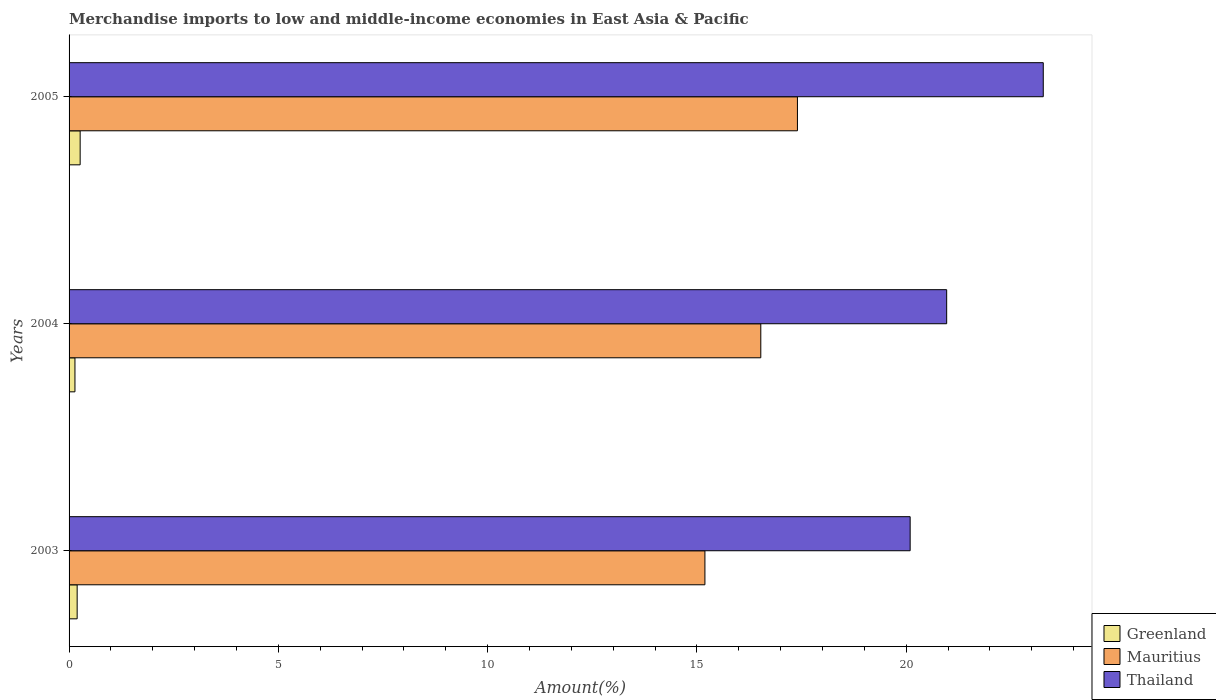How many groups of bars are there?
Offer a terse response. 3. How many bars are there on the 3rd tick from the top?
Your response must be concise. 3. How many bars are there on the 1st tick from the bottom?
Your answer should be compact. 3. What is the percentage of amount earned from merchandise imports in Mauritius in 2003?
Offer a terse response. 15.19. Across all years, what is the maximum percentage of amount earned from merchandise imports in Greenland?
Your answer should be compact. 0.26. Across all years, what is the minimum percentage of amount earned from merchandise imports in Greenland?
Your response must be concise. 0.14. In which year was the percentage of amount earned from merchandise imports in Thailand maximum?
Keep it short and to the point. 2005. What is the total percentage of amount earned from merchandise imports in Greenland in the graph?
Make the answer very short. 0.6. What is the difference between the percentage of amount earned from merchandise imports in Mauritius in 2003 and that in 2004?
Offer a very short reply. -1.33. What is the difference between the percentage of amount earned from merchandise imports in Greenland in 2004 and the percentage of amount earned from merchandise imports in Thailand in 2003?
Provide a short and direct response. -19.95. What is the average percentage of amount earned from merchandise imports in Thailand per year?
Make the answer very short. 21.44. In the year 2003, what is the difference between the percentage of amount earned from merchandise imports in Greenland and percentage of amount earned from merchandise imports in Thailand?
Offer a very short reply. -19.9. What is the ratio of the percentage of amount earned from merchandise imports in Greenland in 2003 to that in 2005?
Your answer should be compact. 0.73. What is the difference between the highest and the second highest percentage of amount earned from merchandise imports in Mauritius?
Keep it short and to the point. 0.88. What is the difference between the highest and the lowest percentage of amount earned from merchandise imports in Mauritius?
Keep it short and to the point. 2.21. Is the sum of the percentage of amount earned from merchandise imports in Mauritius in 2004 and 2005 greater than the maximum percentage of amount earned from merchandise imports in Thailand across all years?
Your answer should be very brief. Yes. What does the 2nd bar from the top in 2004 represents?
Provide a short and direct response. Mauritius. What does the 3rd bar from the bottom in 2005 represents?
Provide a succinct answer. Thailand. Is it the case that in every year, the sum of the percentage of amount earned from merchandise imports in Thailand and percentage of amount earned from merchandise imports in Greenland is greater than the percentage of amount earned from merchandise imports in Mauritius?
Your answer should be very brief. Yes. Are all the bars in the graph horizontal?
Your answer should be compact. Yes. What is the difference between two consecutive major ticks on the X-axis?
Offer a terse response. 5. Does the graph contain any zero values?
Your answer should be very brief. No. How many legend labels are there?
Your answer should be compact. 3. What is the title of the graph?
Offer a very short reply. Merchandise imports to low and middle-income economies in East Asia & Pacific. Does "Belize" appear as one of the legend labels in the graph?
Keep it short and to the point. No. What is the label or title of the X-axis?
Keep it short and to the point. Amount(%). What is the Amount(%) in Greenland in 2003?
Offer a terse response. 0.19. What is the Amount(%) of Mauritius in 2003?
Provide a succinct answer. 15.19. What is the Amount(%) in Thailand in 2003?
Keep it short and to the point. 20.09. What is the Amount(%) of Greenland in 2004?
Ensure brevity in your answer.  0.14. What is the Amount(%) of Mauritius in 2004?
Provide a succinct answer. 16.53. What is the Amount(%) of Thailand in 2004?
Your answer should be very brief. 20.97. What is the Amount(%) in Greenland in 2005?
Keep it short and to the point. 0.26. What is the Amount(%) of Mauritius in 2005?
Provide a succinct answer. 17.4. What is the Amount(%) of Thailand in 2005?
Your response must be concise. 23.27. Across all years, what is the maximum Amount(%) of Greenland?
Keep it short and to the point. 0.26. Across all years, what is the maximum Amount(%) in Mauritius?
Keep it short and to the point. 17.4. Across all years, what is the maximum Amount(%) of Thailand?
Offer a very short reply. 23.27. Across all years, what is the minimum Amount(%) of Greenland?
Make the answer very short. 0.14. Across all years, what is the minimum Amount(%) of Mauritius?
Your response must be concise. 15.19. Across all years, what is the minimum Amount(%) in Thailand?
Keep it short and to the point. 20.09. What is the total Amount(%) in Greenland in the graph?
Provide a short and direct response. 0.6. What is the total Amount(%) in Mauritius in the graph?
Your response must be concise. 49.12. What is the total Amount(%) of Thailand in the graph?
Your response must be concise. 64.33. What is the difference between the Amount(%) of Greenland in 2003 and that in 2004?
Give a very brief answer. 0.05. What is the difference between the Amount(%) of Mauritius in 2003 and that in 2004?
Give a very brief answer. -1.33. What is the difference between the Amount(%) of Thailand in 2003 and that in 2004?
Your answer should be compact. -0.87. What is the difference between the Amount(%) of Greenland in 2003 and that in 2005?
Offer a very short reply. -0.07. What is the difference between the Amount(%) of Mauritius in 2003 and that in 2005?
Provide a short and direct response. -2.21. What is the difference between the Amount(%) of Thailand in 2003 and that in 2005?
Provide a short and direct response. -3.18. What is the difference between the Amount(%) of Greenland in 2004 and that in 2005?
Your response must be concise. -0.12. What is the difference between the Amount(%) in Mauritius in 2004 and that in 2005?
Make the answer very short. -0.88. What is the difference between the Amount(%) in Thailand in 2004 and that in 2005?
Make the answer very short. -2.31. What is the difference between the Amount(%) in Greenland in 2003 and the Amount(%) in Mauritius in 2004?
Keep it short and to the point. -16.33. What is the difference between the Amount(%) of Greenland in 2003 and the Amount(%) of Thailand in 2004?
Make the answer very short. -20.77. What is the difference between the Amount(%) in Mauritius in 2003 and the Amount(%) in Thailand in 2004?
Offer a terse response. -5.78. What is the difference between the Amount(%) in Greenland in 2003 and the Amount(%) in Mauritius in 2005?
Provide a succinct answer. -17.21. What is the difference between the Amount(%) in Greenland in 2003 and the Amount(%) in Thailand in 2005?
Your answer should be very brief. -23.08. What is the difference between the Amount(%) of Mauritius in 2003 and the Amount(%) of Thailand in 2005?
Provide a short and direct response. -8.08. What is the difference between the Amount(%) of Greenland in 2004 and the Amount(%) of Mauritius in 2005?
Your response must be concise. -17.26. What is the difference between the Amount(%) in Greenland in 2004 and the Amount(%) in Thailand in 2005?
Provide a succinct answer. -23.13. What is the difference between the Amount(%) of Mauritius in 2004 and the Amount(%) of Thailand in 2005?
Your answer should be very brief. -6.75. What is the average Amount(%) in Greenland per year?
Keep it short and to the point. 0.2. What is the average Amount(%) in Mauritius per year?
Provide a succinct answer. 16.37. What is the average Amount(%) of Thailand per year?
Offer a very short reply. 21.44. In the year 2003, what is the difference between the Amount(%) in Greenland and Amount(%) in Mauritius?
Your answer should be very brief. -15. In the year 2003, what is the difference between the Amount(%) in Greenland and Amount(%) in Thailand?
Your answer should be compact. -19.9. In the year 2003, what is the difference between the Amount(%) of Mauritius and Amount(%) of Thailand?
Offer a terse response. -4.9. In the year 2004, what is the difference between the Amount(%) in Greenland and Amount(%) in Mauritius?
Keep it short and to the point. -16.38. In the year 2004, what is the difference between the Amount(%) in Greenland and Amount(%) in Thailand?
Ensure brevity in your answer.  -20.83. In the year 2004, what is the difference between the Amount(%) of Mauritius and Amount(%) of Thailand?
Provide a short and direct response. -4.44. In the year 2005, what is the difference between the Amount(%) in Greenland and Amount(%) in Mauritius?
Make the answer very short. -17.14. In the year 2005, what is the difference between the Amount(%) in Greenland and Amount(%) in Thailand?
Your answer should be very brief. -23.01. In the year 2005, what is the difference between the Amount(%) of Mauritius and Amount(%) of Thailand?
Offer a terse response. -5.87. What is the ratio of the Amount(%) of Greenland in 2003 to that in 2004?
Offer a terse response. 1.38. What is the ratio of the Amount(%) of Mauritius in 2003 to that in 2004?
Keep it short and to the point. 0.92. What is the ratio of the Amount(%) in Thailand in 2003 to that in 2004?
Provide a succinct answer. 0.96. What is the ratio of the Amount(%) of Greenland in 2003 to that in 2005?
Ensure brevity in your answer.  0.73. What is the ratio of the Amount(%) in Mauritius in 2003 to that in 2005?
Offer a very short reply. 0.87. What is the ratio of the Amount(%) in Thailand in 2003 to that in 2005?
Your answer should be very brief. 0.86. What is the ratio of the Amount(%) in Greenland in 2004 to that in 2005?
Your answer should be compact. 0.53. What is the ratio of the Amount(%) of Mauritius in 2004 to that in 2005?
Offer a terse response. 0.95. What is the ratio of the Amount(%) of Thailand in 2004 to that in 2005?
Offer a terse response. 0.9. What is the difference between the highest and the second highest Amount(%) of Greenland?
Offer a terse response. 0.07. What is the difference between the highest and the second highest Amount(%) of Mauritius?
Offer a terse response. 0.88. What is the difference between the highest and the second highest Amount(%) in Thailand?
Make the answer very short. 2.31. What is the difference between the highest and the lowest Amount(%) in Greenland?
Offer a terse response. 0.12. What is the difference between the highest and the lowest Amount(%) of Mauritius?
Your answer should be compact. 2.21. What is the difference between the highest and the lowest Amount(%) in Thailand?
Your response must be concise. 3.18. 